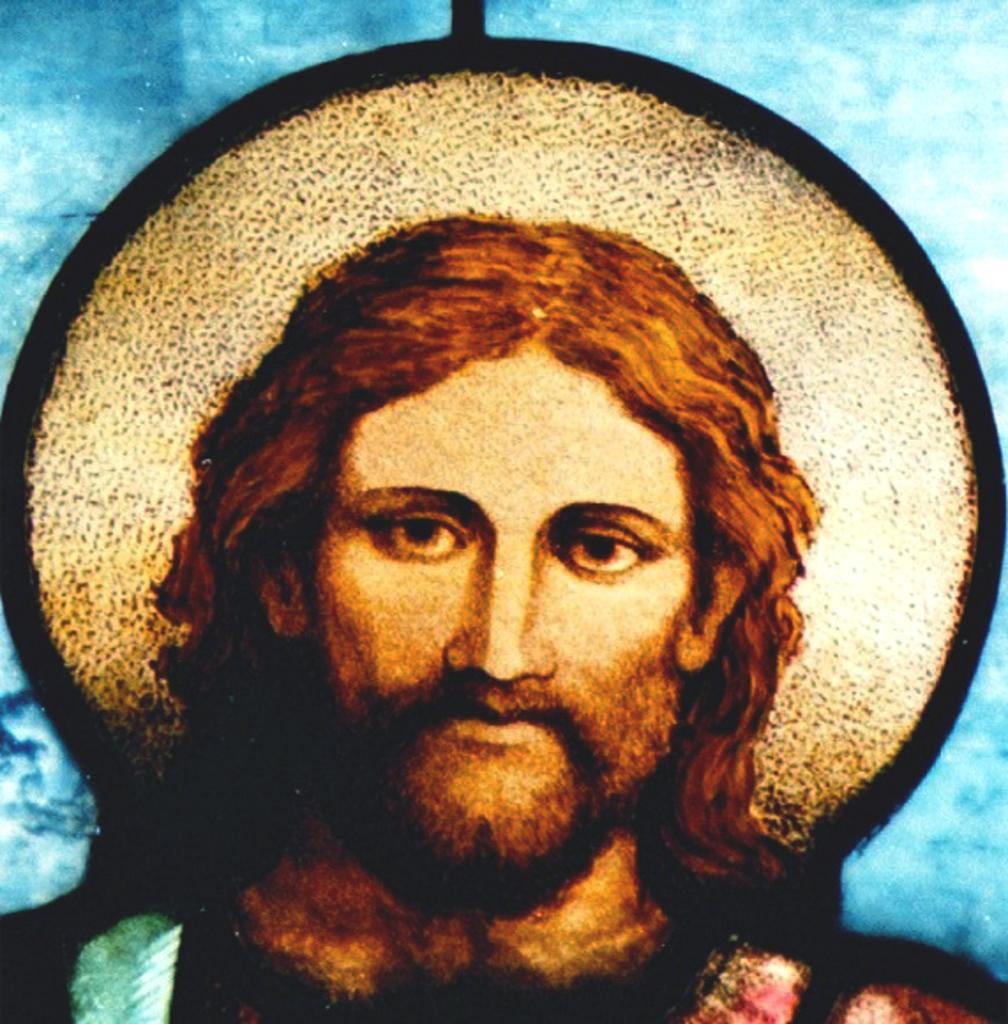Can you describe this image briefly? This is a animated image in this image in the center there is a statue, and in the background there is wall. 